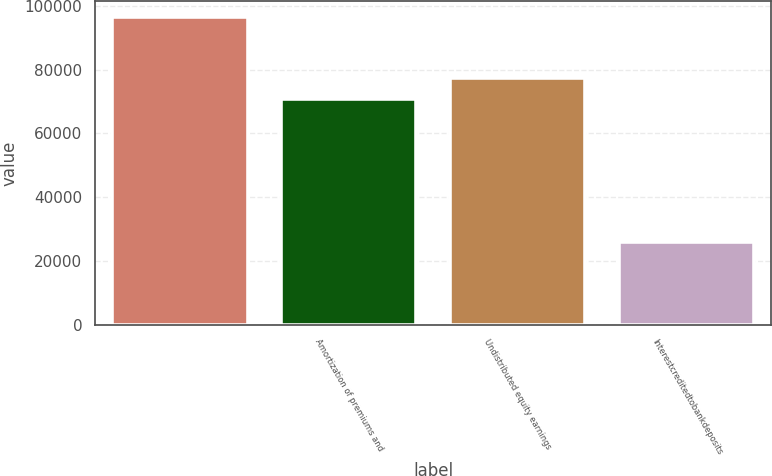Convert chart. <chart><loc_0><loc_0><loc_500><loc_500><bar_chart><ecel><fcel>Amortization of premiums and<fcel>Undistributed equity earnings<fcel>Interestcreditedtobankdeposits<nl><fcel>96620.5<fcel>70866.5<fcel>77305<fcel>25797<nl></chart> 